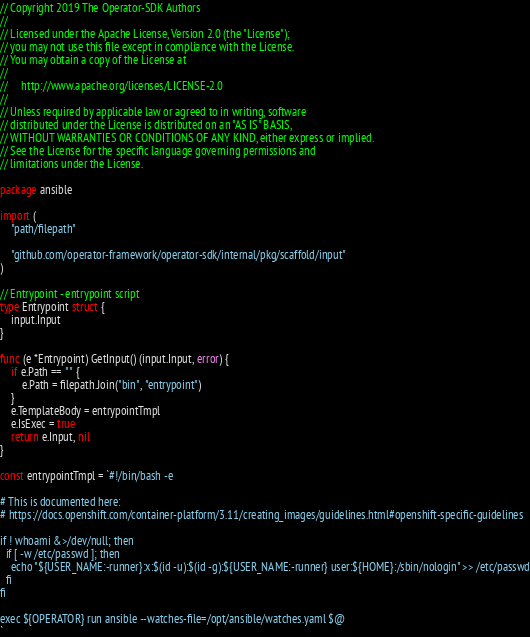Convert code to text. <code><loc_0><loc_0><loc_500><loc_500><_Go_>// Copyright 2019 The Operator-SDK Authors
//
// Licensed under the Apache License, Version 2.0 (the "License");
// you may not use this file except in compliance with the License.
// You may obtain a copy of the License at
//
//     http://www.apache.org/licenses/LICENSE-2.0
//
// Unless required by applicable law or agreed to in writing, software
// distributed under the License is distributed on an "AS IS" BASIS,
// WITHOUT WARRANTIES OR CONDITIONS OF ANY KIND, either express or implied.
// See the License for the specific language governing permissions and
// limitations under the License.

package ansible

import (
	"path/filepath"

	"github.com/operator-framework/operator-sdk/internal/pkg/scaffold/input"
)

// Entrypoint - entrypoint script
type Entrypoint struct {
	input.Input
}

func (e *Entrypoint) GetInput() (input.Input, error) {
	if e.Path == "" {
		e.Path = filepath.Join("bin", "entrypoint")
	}
	e.TemplateBody = entrypointTmpl
	e.IsExec = true
	return e.Input, nil
}

const entrypointTmpl = `#!/bin/bash -e

# This is documented here:
# https://docs.openshift.com/container-platform/3.11/creating_images/guidelines.html#openshift-specific-guidelines

if ! whoami &>/dev/null; then
  if [ -w /etc/passwd ]; then
    echo "${USER_NAME:-runner}:x:$(id -u):$(id -g):${USER_NAME:-runner} user:${HOME}:/sbin/nologin" >> /etc/passwd
  fi
fi

exec ${OPERATOR} run ansible --watches-file=/opt/ansible/watches.yaml $@
`
</code> 